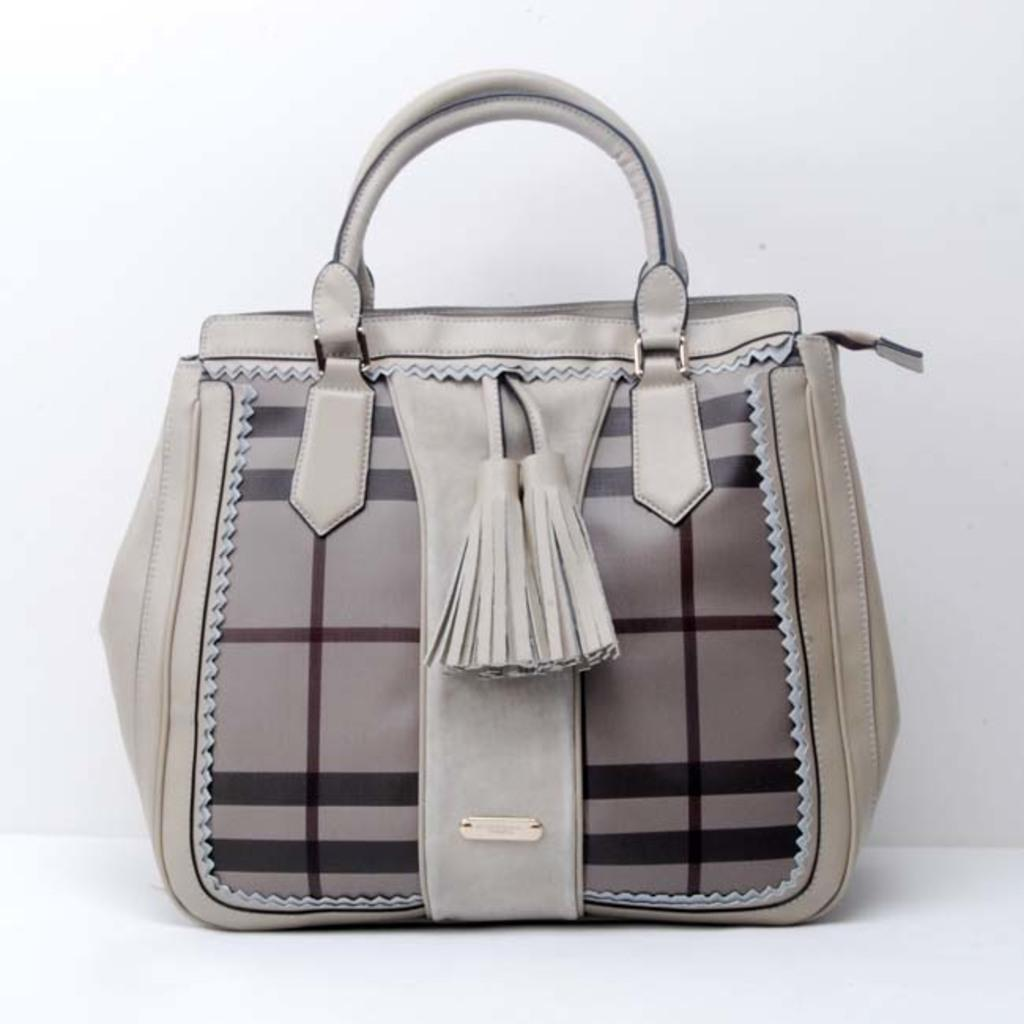What object is visible in the image? There is a hand purse in the image. Where is the hand purse located? The hand purse is on a table. What type of advertisement is displayed on the hand purse in the image? There is no advertisement present on the hand purse in the image. How many quarters can be seen inside the hand purse in the image? There are no quarters visible in the image, as it only shows a hand purse on a table. 